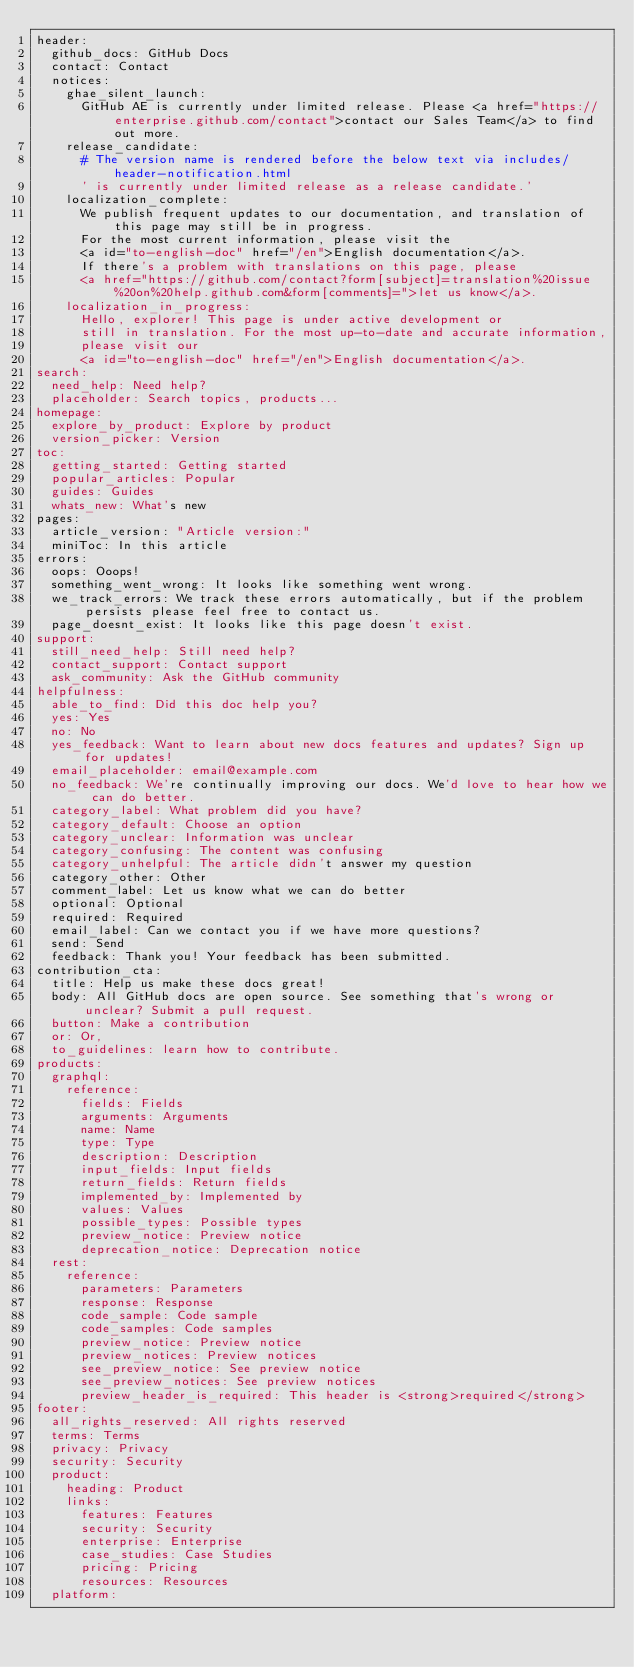<code> <loc_0><loc_0><loc_500><loc_500><_YAML_>header:
  github_docs: GitHub Docs
  contact: Contact
  notices:
    ghae_silent_launch:
      GitHub AE is currently under limited release. Please <a href="https://enterprise.github.com/contact">contact our Sales Team</a> to find out more.
    release_candidate:
      # The version name is rendered before the below text via includes/header-notification.html
      ' is currently under limited release as a release candidate.'
    localization_complete:
      We publish frequent updates to our documentation, and translation of this page may still be in progress.
      For the most current information, please visit the
      <a id="to-english-doc" href="/en">English documentation</a>.
      If there's a problem with translations on this page, please
      <a href="https://github.com/contact?form[subject]=translation%20issue%20on%20help.github.com&form[comments]=">let us know</a>.
    localization_in_progress:
      Hello, explorer! This page is under active development or
      still in translation. For the most up-to-date and accurate information,
      please visit our
      <a id="to-english-doc" href="/en">English documentation</a>.
search:
  need_help: Need help?
  placeholder: Search topics, products...
homepage:
  explore_by_product: Explore by product
  version_picker: Version
toc:
  getting_started: Getting started
  popular_articles: Popular
  guides: Guides
  whats_new: What's new
pages:
  article_version: "Article version:"
  miniToc: In this article
errors:
  oops: Ooops!
  something_went_wrong: It looks like something went wrong.
  we_track_errors: We track these errors automatically, but if the problem persists please feel free to contact us.
  page_doesnt_exist: It looks like this page doesn't exist.
support:
  still_need_help: Still need help?
  contact_support: Contact support
  ask_community: Ask the GitHub community
helpfulness:
  able_to_find: Did this doc help you?
  yes: Yes
  no: No
  yes_feedback: Want to learn about new docs features and updates? Sign up for updates!
  email_placeholder: email@example.com
  no_feedback: We're continually improving our docs. We'd love to hear how we can do better.
  category_label: What problem did you have?
  category_default: Choose an option
  category_unclear: Information was unclear
  category_confusing: The content was confusing
  category_unhelpful: The article didn't answer my question
  category_other: Other
  comment_label: Let us know what we can do better
  optional: Optional
  required: Required
  email_label: Can we contact you if we have more questions?
  send: Send
  feedback: Thank you! Your feedback has been submitted.
contribution_cta:
  title: Help us make these docs great!
  body: All GitHub docs are open source. See something that's wrong or unclear? Submit a pull request.
  button: Make a contribution
  or: Or,
  to_guidelines: learn how to contribute.
products:
  graphql:
    reference:
      fields: Fields
      arguments: Arguments
      name: Name
      type: Type
      description: Description
      input_fields: Input fields
      return_fields: Return fields
      implemented_by: Implemented by
      values: Values
      possible_types: Possible types
      preview_notice: Preview notice
      deprecation_notice: Deprecation notice
  rest:
    reference:
      parameters: Parameters
      response: Response
      code_sample: Code sample
      code_samples: Code samples
      preview_notice: Preview notice
      preview_notices: Preview notices
      see_preview_notice: See preview notice
      see_preview_notices: See preview notices
      preview_header_is_required: This header is <strong>required</strong>
footer:
  all_rights_reserved: All rights reserved
  terms: Terms
  privacy: Privacy
  security: Security
  product:
    heading: Product
    links:
      features: Features
      security: Security
      enterprise: Enterprise
      case_studies: Case Studies
      pricing: Pricing
      resources: Resources
  platform:</code> 